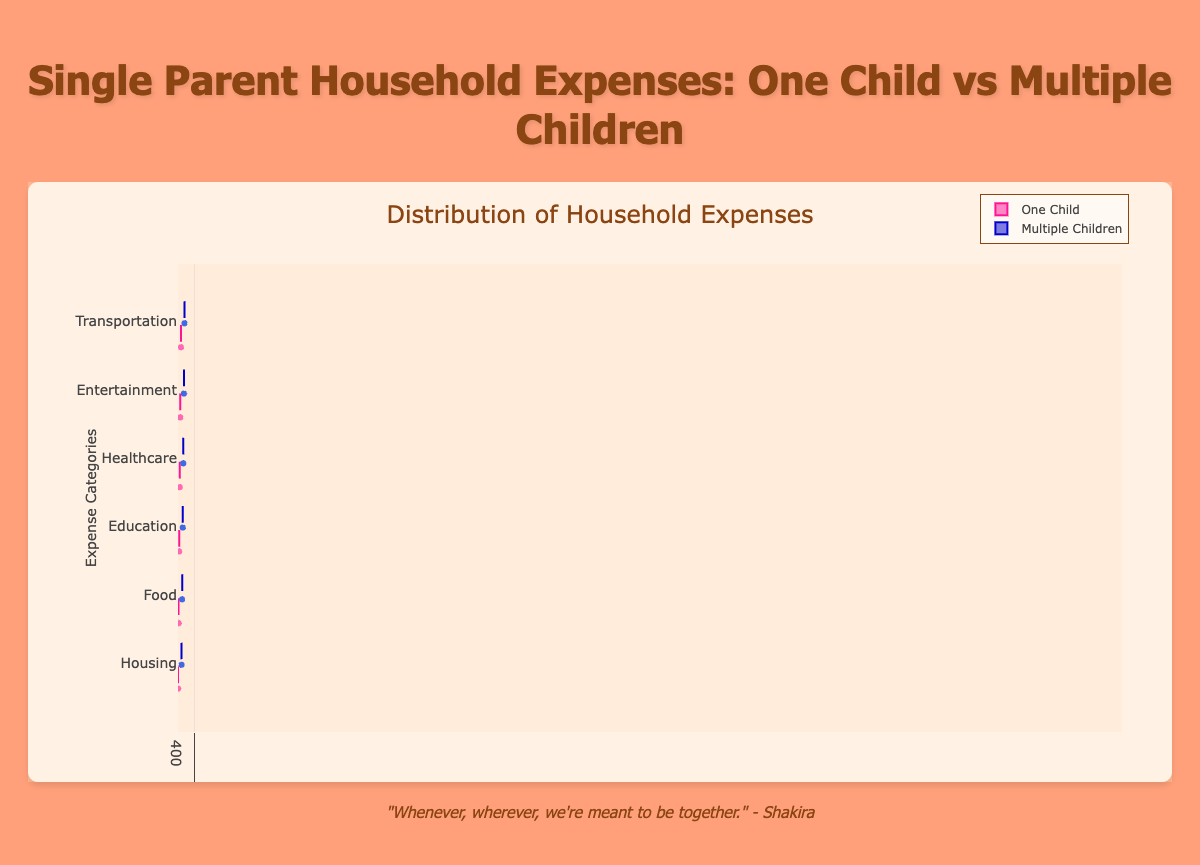What is the title of the chart? The title of a chart is the main heading that describes what the chart is about, usually found at the top of the chart. In this figure, the title is prominently styled and placed.
Answer: Single Parent Household Expenses: One Child vs Multiple Children What are the categories of household expenses shown in the figure? The categories of household expenses are listed along the y-axis, representing different types of expenses analyzed in the box plot.
Answer: Housing, Food, Education, Healthcare, Entertainment, Transportation Which expense category has the highest median value for Single Parents with Multiple Children? To find this, compare the median lines within each box plot for the "Single Parent Multiple Children" group. The highest median value indicates the top expense. The median line is marked in the middle of each box.
Answer: Housing In which expense category is the difference between Single Parents with One Child and Multiple Children the greatest? By comparing the median lines for each category, look for the biggest gap between the median of "Single Parent One Child" and "Single Parent Multiple Children." Deduct the amount for Single Parents with One Child from the amount for Single Parents with Multiple Children.
Answer: Housing What category has the widest range of household expenses for single parents with one child? The range in a box plot is indicated by the distance between the smallest and largest values within the whiskers. For Single Parents with One Child, observe the length of the whiskers in each category to determine which is the longest.
Answer: Healthcare Which category has the smallest interquartile range (IQR) for single parents with multiple children? The IQR is the range between the 25th and 75th percentiles, shown as the box in the box plot. For Single Parents with Multiple Children, find the box with the smallest height.
Answer: Food Which group's median expense on Education is higher? To determine this, compare the median lines within the "Education" category. The higher median line indicates which group spends more.
Answer: Multiple Children In the "Food" category, what is the approximate difference between the median expense for Single Parents with One Child and those with Multiple Children? The median is the horizontal line within each box. Locate the medians for both groups in the "Food" category and subtract the one child's median from the multiple children's median.
Answer: Approximately $200 Which category shows the least variability in expenses for single parents with multiple children? Variability is depicted by the box height and whisker lengths. For Multiple Children, the shortest box and whiskers indicate the least variability.
Answer: Food Are there any outliers in the "Healthcare" expenses for both groups? Outliers are represented by individual points outside the whiskers. In the "Healthcare" category, look for any such points on the box plot for both groups.
Answer: Yes 